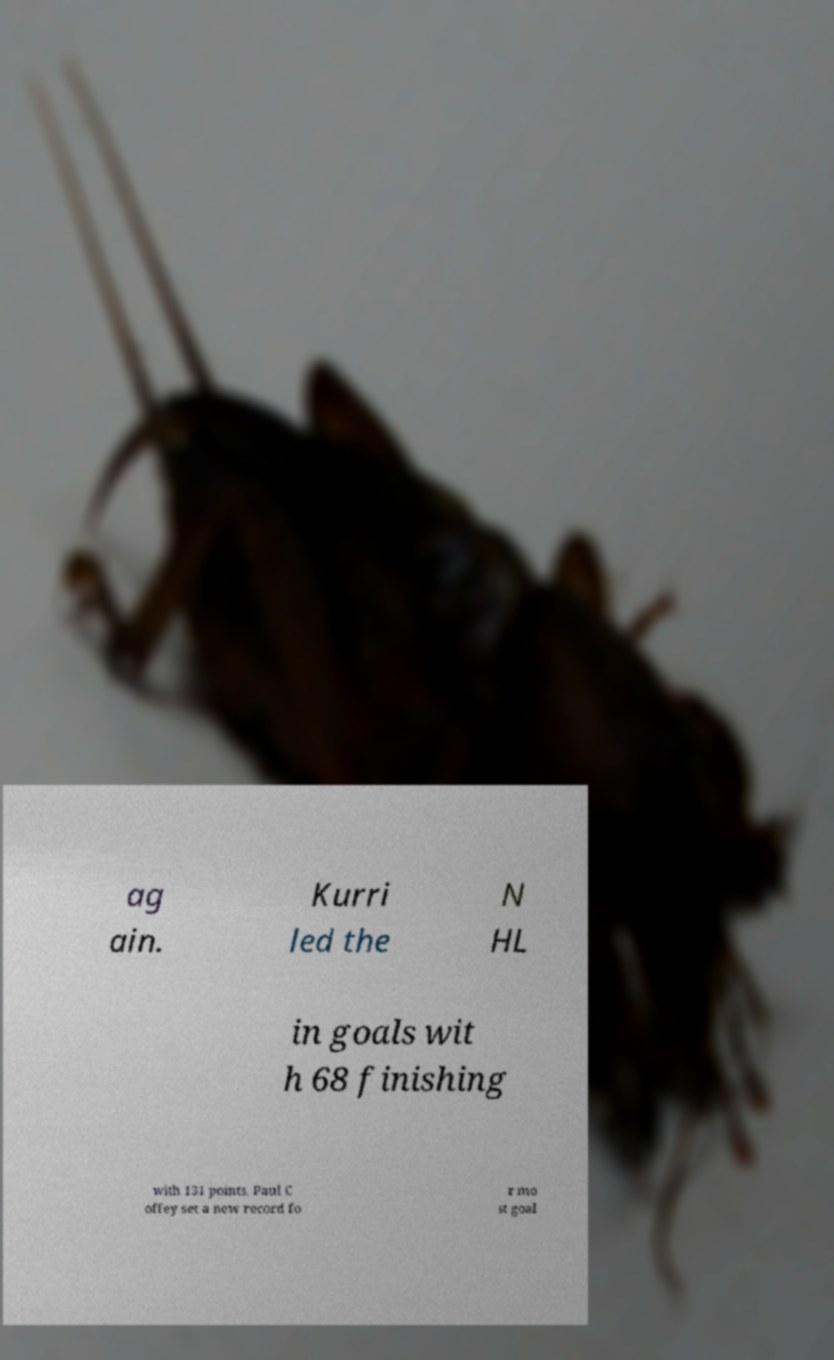Could you extract and type out the text from this image? ag ain. Kurri led the N HL in goals wit h 68 finishing with 131 points. Paul C offey set a new record fo r mo st goal 